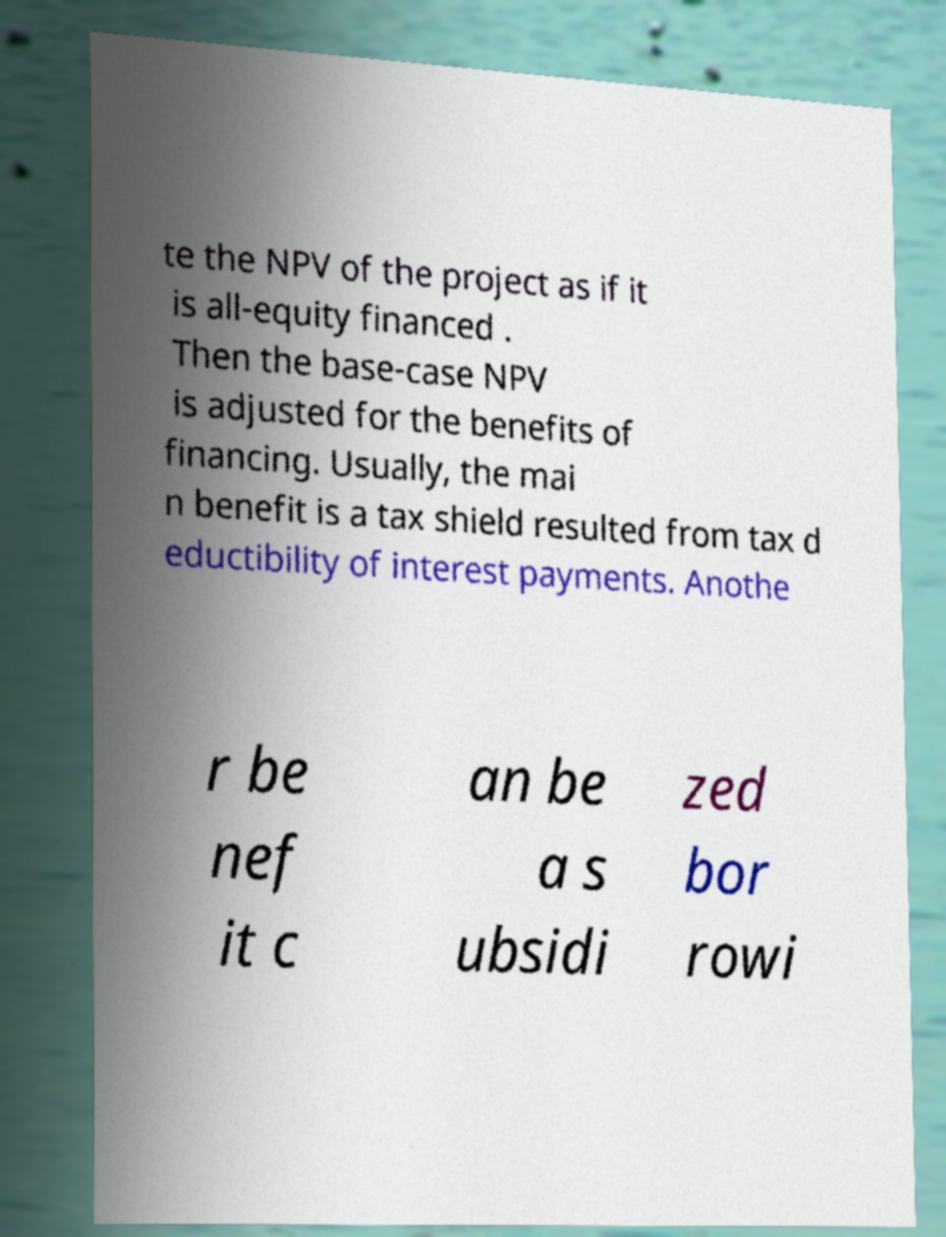What messages or text are displayed in this image? I need them in a readable, typed format. te the NPV of the project as if it is all-equity financed . Then the base-case NPV is adjusted for the benefits of financing. Usually, the mai n benefit is a tax shield resulted from tax d eductibility of interest payments. Anothe r be nef it c an be a s ubsidi zed bor rowi 